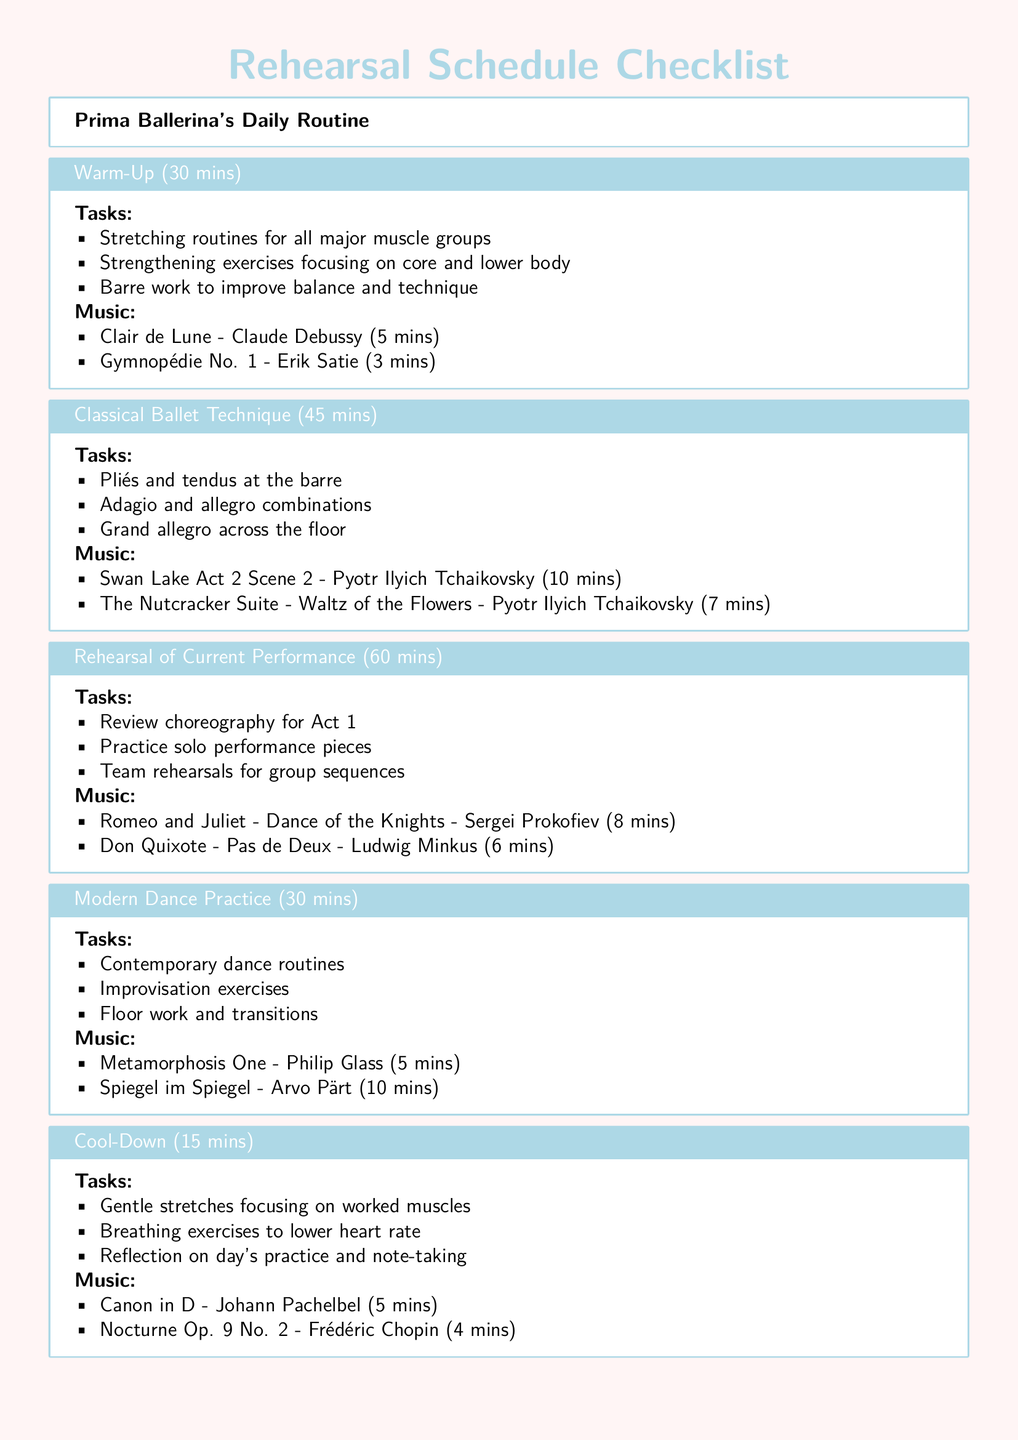what is the duration of the warm-up? The warm-up section specifies that it lasts for 30 minutes.
Answer: 30 mins who composed "Swan Lake Act 2 Scene 2"? The document notes that "Swan Lake Act 2 Scene 2" is composed by Pyotr Ilyich Tchaikovsky.
Answer: Pyotr Ilyich Tchaikovsky how long is the rehearsal of the current performance? The rehearsal of the current performance is noted as lasting for 60 minutes.
Answer: 60 mins which piece by Philip Glass is selected for modern dance practice? The document lists "Metamorphosis One" by Philip Glass for modern dance practice.
Answer: Metamorphosis One what type of exercises are included in the cool-down? The cool-down includes breathing exercises aimed at lowering the heart rate.
Answer: Breathing exercises how many music selections are there for classical ballet technique? There are two music selections listed under the classical ballet technique section.
Answer: Two what is the total duration of music selections in the warm-up? The warm-up includes "Clair de Lune" (5 mins) and "Gymnopédie No. 1" (3 mins), totaling 8 minutes.
Answer: 8 mins what activity follows the modern dance practice? According to the checklist, the next activity after modern dance practice is the cool-down.
Answer: Cool-Down 